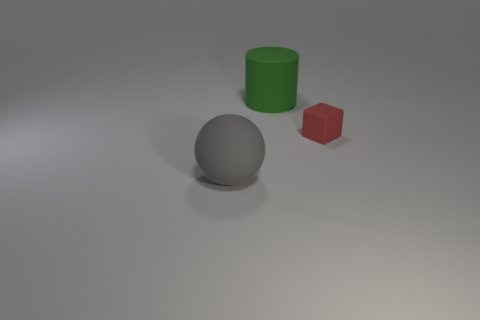Is the number of tiny red things that are on the right side of the rubber sphere the same as the number of large balls?
Your response must be concise. Yes. There is a red cube; are there any objects in front of it?
Offer a very short reply. Yes. There is a object that is on the right side of the big thing behind the matte sphere that is left of the red block; what size is it?
Your answer should be compact. Small. How many red blocks are made of the same material as the big gray thing?
Provide a short and direct response. 1. What shape is the large thing left of the thing that is behind the cube?
Your response must be concise. Sphere. There is a thing on the right side of the green rubber object; what is its shape?
Offer a very short reply. Cube. What number of other cylinders are the same color as the rubber cylinder?
Your answer should be compact. 0. The cylinder is what color?
Provide a short and direct response. Green. How many large green matte cylinders are behind the rubber object that is to the left of the big cylinder?
Your response must be concise. 1. There is a red rubber thing; is it the same size as the rubber object to the left of the green object?
Offer a terse response. No. 